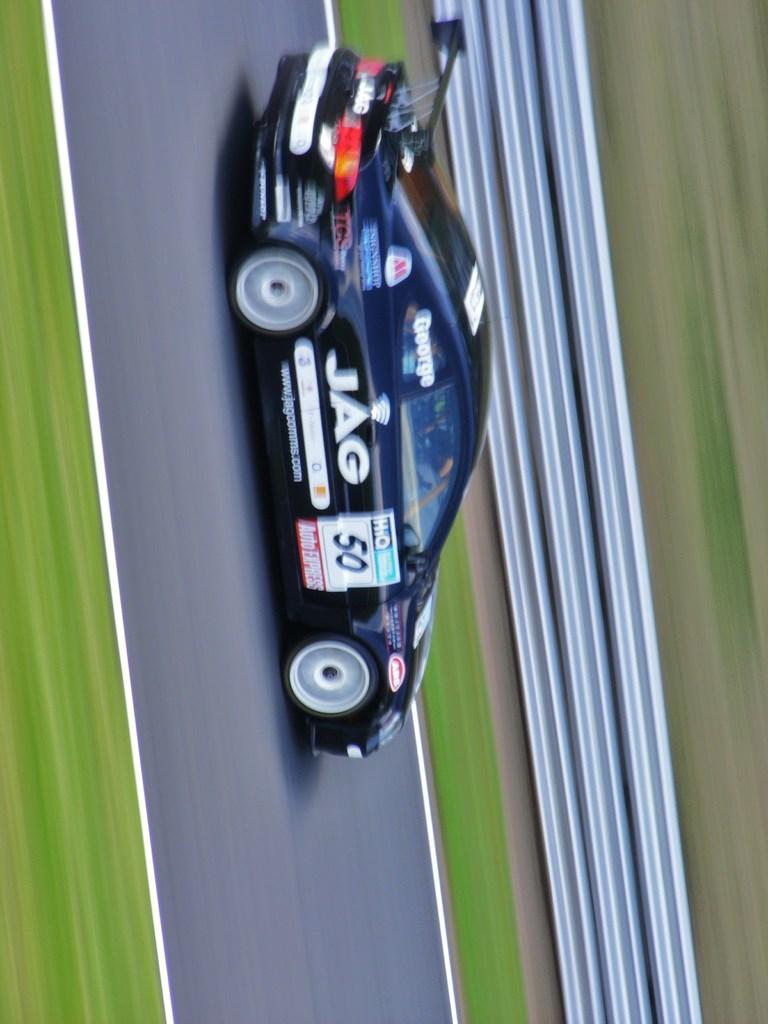What is the main subject in the center of the image? There is a car in the center of the image. What can be seen in the background of the image? There is a fence in the image. What is located at the bottom of the image? The bottom of the image contains a road. What type of surface is visible in the image? The ground is visible in the image. What type of copper material can be seen in the image? There is no copper material present in the image. Is the grandfather visible in the image? There is no mention of a grandfather in the image, so it cannot be determined if he is present. 